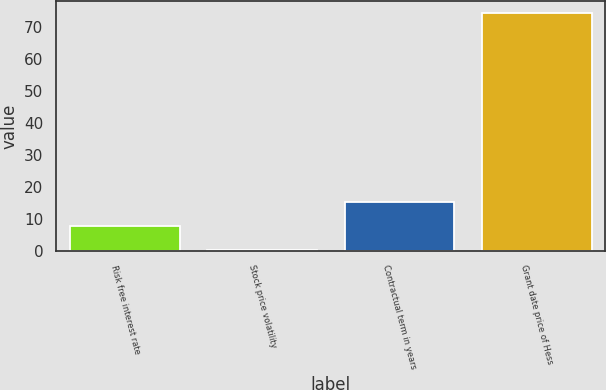<chart> <loc_0><loc_0><loc_500><loc_500><bar_chart><fcel>Risk free interest rate<fcel>Stock price volatility<fcel>Contractual term in years<fcel>Grant date price of Hess<nl><fcel>7.69<fcel>0.27<fcel>15.11<fcel>74.49<nl></chart> 